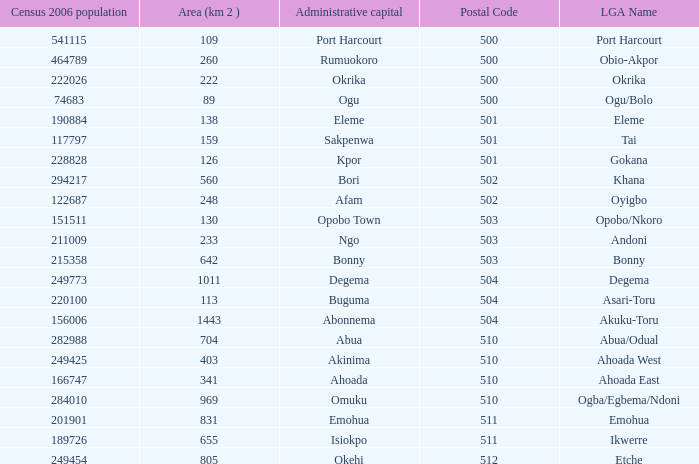What is the area when the Iga name is Ahoada East? 341.0. 